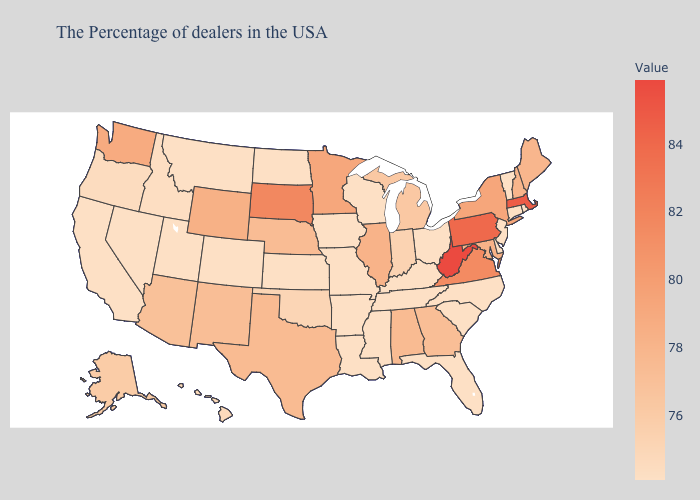Among the states that border Ohio , does Michigan have the highest value?
Quick response, please. No. Does Rhode Island have the highest value in the Northeast?
Concise answer only. No. Which states have the lowest value in the USA?
Short answer required. Rhode Island, Vermont, Connecticut, New Jersey, Delaware, North Carolina, South Carolina, Ohio, Florida, Kentucky, Tennessee, Wisconsin, Mississippi, Louisiana, Missouri, Arkansas, Iowa, Kansas, North Dakota, Colorado, Utah, Montana, Nevada, California. Does Montana have the lowest value in the USA?
Keep it brief. Yes. Which states have the lowest value in the USA?
Give a very brief answer. Rhode Island, Vermont, Connecticut, New Jersey, Delaware, North Carolina, South Carolina, Ohio, Florida, Kentucky, Tennessee, Wisconsin, Mississippi, Louisiana, Missouri, Arkansas, Iowa, Kansas, North Dakota, Colorado, Utah, Montana, Nevada, California. Does Rhode Island have a higher value than Arizona?
Concise answer only. No. 